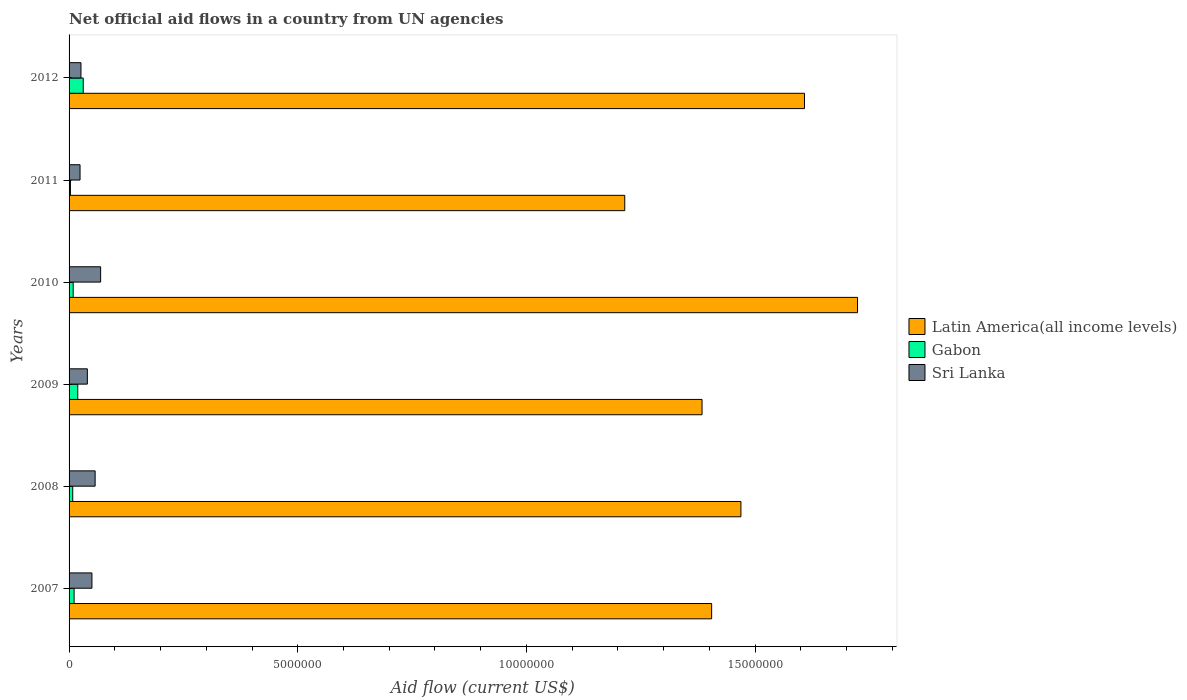How many different coloured bars are there?
Keep it short and to the point. 3. Are the number of bars on each tick of the Y-axis equal?
Your response must be concise. Yes. How many bars are there on the 6th tick from the top?
Your answer should be compact. 3. How many bars are there on the 5th tick from the bottom?
Your answer should be compact. 3. What is the label of the 6th group of bars from the top?
Your answer should be compact. 2007. What is the net official aid flow in Gabon in 2012?
Give a very brief answer. 3.10e+05. Across all years, what is the maximum net official aid flow in Sri Lanka?
Give a very brief answer. 6.90e+05. Across all years, what is the minimum net official aid flow in Gabon?
Your answer should be very brief. 3.00e+04. What is the total net official aid flow in Sri Lanka in the graph?
Offer a very short reply. 2.66e+06. What is the difference between the net official aid flow in Gabon in 2009 and that in 2011?
Make the answer very short. 1.60e+05. What is the difference between the net official aid flow in Gabon in 2009 and the net official aid flow in Latin America(all income levels) in 2007?
Make the answer very short. -1.39e+07. What is the average net official aid flow in Sri Lanka per year?
Make the answer very short. 4.43e+05. In the year 2012, what is the difference between the net official aid flow in Sri Lanka and net official aid flow in Latin America(all income levels)?
Your response must be concise. -1.58e+07. In how many years, is the net official aid flow in Gabon greater than 13000000 US$?
Give a very brief answer. 0. What is the ratio of the net official aid flow in Latin America(all income levels) in 2007 to that in 2011?
Keep it short and to the point. 1.16. Is the net official aid flow in Sri Lanka in 2010 less than that in 2012?
Your answer should be compact. No. Is the difference between the net official aid flow in Sri Lanka in 2008 and 2009 greater than the difference between the net official aid flow in Latin America(all income levels) in 2008 and 2009?
Your answer should be compact. No. What is the difference between the highest and the lowest net official aid flow in Latin America(all income levels)?
Ensure brevity in your answer.  5.09e+06. In how many years, is the net official aid flow in Gabon greater than the average net official aid flow in Gabon taken over all years?
Give a very brief answer. 2. What does the 2nd bar from the top in 2012 represents?
Provide a succinct answer. Gabon. What does the 2nd bar from the bottom in 2009 represents?
Provide a short and direct response. Gabon. How many bars are there?
Ensure brevity in your answer.  18. What is the difference between two consecutive major ticks on the X-axis?
Your answer should be compact. 5.00e+06. Are the values on the major ticks of X-axis written in scientific E-notation?
Offer a very short reply. No. Where does the legend appear in the graph?
Offer a terse response. Center right. How many legend labels are there?
Provide a short and direct response. 3. What is the title of the graph?
Your answer should be compact. Net official aid flows in a country from UN agencies. Does "Cuba" appear as one of the legend labels in the graph?
Keep it short and to the point. No. What is the label or title of the X-axis?
Ensure brevity in your answer.  Aid flow (current US$). What is the label or title of the Y-axis?
Your response must be concise. Years. What is the Aid flow (current US$) in Latin America(all income levels) in 2007?
Make the answer very short. 1.40e+07. What is the Aid flow (current US$) of Gabon in 2007?
Your answer should be compact. 1.10e+05. What is the Aid flow (current US$) in Latin America(all income levels) in 2008?
Offer a terse response. 1.47e+07. What is the Aid flow (current US$) of Sri Lanka in 2008?
Offer a terse response. 5.70e+05. What is the Aid flow (current US$) in Latin America(all income levels) in 2009?
Give a very brief answer. 1.38e+07. What is the Aid flow (current US$) in Gabon in 2009?
Provide a succinct answer. 1.90e+05. What is the Aid flow (current US$) in Sri Lanka in 2009?
Your response must be concise. 4.00e+05. What is the Aid flow (current US$) of Latin America(all income levels) in 2010?
Provide a succinct answer. 1.72e+07. What is the Aid flow (current US$) in Gabon in 2010?
Provide a short and direct response. 9.00e+04. What is the Aid flow (current US$) of Sri Lanka in 2010?
Your response must be concise. 6.90e+05. What is the Aid flow (current US$) of Latin America(all income levels) in 2011?
Ensure brevity in your answer.  1.22e+07. What is the Aid flow (current US$) of Gabon in 2011?
Provide a short and direct response. 3.00e+04. What is the Aid flow (current US$) in Sri Lanka in 2011?
Offer a terse response. 2.40e+05. What is the Aid flow (current US$) in Latin America(all income levels) in 2012?
Provide a succinct answer. 1.61e+07. What is the Aid flow (current US$) in Gabon in 2012?
Your response must be concise. 3.10e+05. What is the Aid flow (current US$) of Sri Lanka in 2012?
Provide a succinct answer. 2.60e+05. Across all years, what is the maximum Aid flow (current US$) in Latin America(all income levels)?
Keep it short and to the point. 1.72e+07. Across all years, what is the maximum Aid flow (current US$) in Gabon?
Give a very brief answer. 3.10e+05. Across all years, what is the maximum Aid flow (current US$) in Sri Lanka?
Your answer should be very brief. 6.90e+05. Across all years, what is the minimum Aid flow (current US$) of Latin America(all income levels)?
Provide a succinct answer. 1.22e+07. Across all years, what is the minimum Aid flow (current US$) of Sri Lanka?
Give a very brief answer. 2.40e+05. What is the total Aid flow (current US$) in Latin America(all income levels) in the graph?
Ensure brevity in your answer.  8.80e+07. What is the total Aid flow (current US$) of Gabon in the graph?
Keep it short and to the point. 8.10e+05. What is the total Aid flow (current US$) in Sri Lanka in the graph?
Keep it short and to the point. 2.66e+06. What is the difference between the Aid flow (current US$) of Latin America(all income levels) in 2007 and that in 2008?
Give a very brief answer. -6.40e+05. What is the difference between the Aid flow (current US$) in Latin America(all income levels) in 2007 and that in 2009?
Keep it short and to the point. 2.10e+05. What is the difference between the Aid flow (current US$) of Latin America(all income levels) in 2007 and that in 2010?
Provide a succinct answer. -3.19e+06. What is the difference between the Aid flow (current US$) in Gabon in 2007 and that in 2010?
Offer a very short reply. 2.00e+04. What is the difference between the Aid flow (current US$) of Latin America(all income levels) in 2007 and that in 2011?
Your response must be concise. 1.90e+06. What is the difference between the Aid flow (current US$) in Gabon in 2007 and that in 2011?
Give a very brief answer. 8.00e+04. What is the difference between the Aid flow (current US$) of Latin America(all income levels) in 2007 and that in 2012?
Your answer should be compact. -2.03e+06. What is the difference between the Aid flow (current US$) in Sri Lanka in 2007 and that in 2012?
Ensure brevity in your answer.  2.40e+05. What is the difference between the Aid flow (current US$) in Latin America(all income levels) in 2008 and that in 2009?
Ensure brevity in your answer.  8.50e+05. What is the difference between the Aid flow (current US$) of Gabon in 2008 and that in 2009?
Your answer should be compact. -1.10e+05. What is the difference between the Aid flow (current US$) of Sri Lanka in 2008 and that in 2009?
Your answer should be very brief. 1.70e+05. What is the difference between the Aid flow (current US$) in Latin America(all income levels) in 2008 and that in 2010?
Your answer should be very brief. -2.55e+06. What is the difference between the Aid flow (current US$) of Sri Lanka in 2008 and that in 2010?
Offer a very short reply. -1.20e+05. What is the difference between the Aid flow (current US$) in Latin America(all income levels) in 2008 and that in 2011?
Your answer should be compact. 2.54e+06. What is the difference between the Aid flow (current US$) in Gabon in 2008 and that in 2011?
Offer a very short reply. 5.00e+04. What is the difference between the Aid flow (current US$) of Latin America(all income levels) in 2008 and that in 2012?
Keep it short and to the point. -1.39e+06. What is the difference between the Aid flow (current US$) of Latin America(all income levels) in 2009 and that in 2010?
Give a very brief answer. -3.40e+06. What is the difference between the Aid flow (current US$) in Gabon in 2009 and that in 2010?
Keep it short and to the point. 1.00e+05. What is the difference between the Aid flow (current US$) in Sri Lanka in 2009 and that in 2010?
Your response must be concise. -2.90e+05. What is the difference between the Aid flow (current US$) of Latin America(all income levels) in 2009 and that in 2011?
Your answer should be compact. 1.69e+06. What is the difference between the Aid flow (current US$) in Gabon in 2009 and that in 2011?
Your response must be concise. 1.60e+05. What is the difference between the Aid flow (current US$) of Latin America(all income levels) in 2009 and that in 2012?
Make the answer very short. -2.24e+06. What is the difference between the Aid flow (current US$) in Sri Lanka in 2009 and that in 2012?
Give a very brief answer. 1.40e+05. What is the difference between the Aid flow (current US$) of Latin America(all income levels) in 2010 and that in 2011?
Make the answer very short. 5.09e+06. What is the difference between the Aid flow (current US$) of Latin America(all income levels) in 2010 and that in 2012?
Offer a very short reply. 1.16e+06. What is the difference between the Aid flow (current US$) in Sri Lanka in 2010 and that in 2012?
Your answer should be compact. 4.30e+05. What is the difference between the Aid flow (current US$) of Latin America(all income levels) in 2011 and that in 2012?
Your answer should be very brief. -3.93e+06. What is the difference between the Aid flow (current US$) of Gabon in 2011 and that in 2012?
Keep it short and to the point. -2.80e+05. What is the difference between the Aid flow (current US$) of Sri Lanka in 2011 and that in 2012?
Keep it short and to the point. -2.00e+04. What is the difference between the Aid flow (current US$) in Latin America(all income levels) in 2007 and the Aid flow (current US$) in Gabon in 2008?
Give a very brief answer. 1.40e+07. What is the difference between the Aid flow (current US$) of Latin America(all income levels) in 2007 and the Aid flow (current US$) of Sri Lanka in 2008?
Your answer should be very brief. 1.35e+07. What is the difference between the Aid flow (current US$) in Gabon in 2007 and the Aid flow (current US$) in Sri Lanka in 2008?
Keep it short and to the point. -4.60e+05. What is the difference between the Aid flow (current US$) of Latin America(all income levels) in 2007 and the Aid flow (current US$) of Gabon in 2009?
Keep it short and to the point. 1.39e+07. What is the difference between the Aid flow (current US$) in Latin America(all income levels) in 2007 and the Aid flow (current US$) in Sri Lanka in 2009?
Your answer should be compact. 1.36e+07. What is the difference between the Aid flow (current US$) in Latin America(all income levels) in 2007 and the Aid flow (current US$) in Gabon in 2010?
Keep it short and to the point. 1.40e+07. What is the difference between the Aid flow (current US$) of Latin America(all income levels) in 2007 and the Aid flow (current US$) of Sri Lanka in 2010?
Offer a terse response. 1.34e+07. What is the difference between the Aid flow (current US$) in Gabon in 2007 and the Aid flow (current US$) in Sri Lanka in 2010?
Your response must be concise. -5.80e+05. What is the difference between the Aid flow (current US$) in Latin America(all income levels) in 2007 and the Aid flow (current US$) in Gabon in 2011?
Your response must be concise. 1.40e+07. What is the difference between the Aid flow (current US$) in Latin America(all income levels) in 2007 and the Aid flow (current US$) in Sri Lanka in 2011?
Give a very brief answer. 1.38e+07. What is the difference between the Aid flow (current US$) of Latin America(all income levels) in 2007 and the Aid flow (current US$) of Gabon in 2012?
Ensure brevity in your answer.  1.37e+07. What is the difference between the Aid flow (current US$) in Latin America(all income levels) in 2007 and the Aid flow (current US$) in Sri Lanka in 2012?
Offer a very short reply. 1.38e+07. What is the difference between the Aid flow (current US$) in Gabon in 2007 and the Aid flow (current US$) in Sri Lanka in 2012?
Make the answer very short. -1.50e+05. What is the difference between the Aid flow (current US$) in Latin America(all income levels) in 2008 and the Aid flow (current US$) in Gabon in 2009?
Provide a short and direct response. 1.45e+07. What is the difference between the Aid flow (current US$) in Latin America(all income levels) in 2008 and the Aid flow (current US$) in Sri Lanka in 2009?
Give a very brief answer. 1.43e+07. What is the difference between the Aid flow (current US$) of Gabon in 2008 and the Aid flow (current US$) of Sri Lanka in 2009?
Your response must be concise. -3.20e+05. What is the difference between the Aid flow (current US$) of Latin America(all income levels) in 2008 and the Aid flow (current US$) of Gabon in 2010?
Keep it short and to the point. 1.46e+07. What is the difference between the Aid flow (current US$) of Latin America(all income levels) in 2008 and the Aid flow (current US$) of Sri Lanka in 2010?
Give a very brief answer. 1.40e+07. What is the difference between the Aid flow (current US$) of Gabon in 2008 and the Aid flow (current US$) of Sri Lanka in 2010?
Provide a short and direct response. -6.10e+05. What is the difference between the Aid flow (current US$) of Latin America(all income levels) in 2008 and the Aid flow (current US$) of Gabon in 2011?
Offer a very short reply. 1.47e+07. What is the difference between the Aid flow (current US$) in Latin America(all income levels) in 2008 and the Aid flow (current US$) in Sri Lanka in 2011?
Your answer should be compact. 1.44e+07. What is the difference between the Aid flow (current US$) of Gabon in 2008 and the Aid flow (current US$) of Sri Lanka in 2011?
Keep it short and to the point. -1.60e+05. What is the difference between the Aid flow (current US$) in Latin America(all income levels) in 2008 and the Aid flow (current US$) in Gabon in 2012?
Ensure brevity in your answer.  1.44e+07. What is the difference between the Aid flow (current US$) of Latin America(all income levels) in 2008 and the Aid flow (current US$) of Sri Lanka in 2012?
Your answer should be compact. 1.44e+07. What is the difference between the Aid flow (current US$) of Latin America(all income levels) in 2009 and the Aid flow (current US$) of Gabon in 2010?
Offer a very short reply. 1.38e+07. What is the difference between the Aid flow (current US$) in Latin America(all income levels) in 2009 and the Aid flow (current US$) in Sri Lanka in 2010?
Your response must be concise. 1.32e+07. What is the difference between the Aid flow (current US$) in Gabon in 2009 and the Aid flow (current US$) in Sri Lanka in 2010?
Your answer should be compact. -5.00e+05. What is the difference between the Aid flow (current US$) in Latin America(all income levels) in 2009 and the Aid flow (current US$) in Gabon in 2011?
Your answer should be compact. 1.38e+07. What is the difference between the Aid flow (current US$) in Latin America(all income levels) in 2009 and the Aid flow (current US$) in Sri Lanka in 2011?
Provide a short and direct response. 1.36e+07. What is the difference between the Aid flow (current US$) in Latin America(all income levels) in 2009 and the Aid flow (current US$) in Gabon in 2012?
Provide a succinct answer. 1.35e+07. What is the difference between the Aid flow (current US$) of Latin America(all income levels) in 2009 and the Aid flow (current US$) of Sri Lanka in 2012?
Your answer should be compact. 1.36e+07. What is the difference between the Aid flow (current US$) of Gabon in 2009 and the Aid flow (current US$) of Sri Lanka in 2012?
Offer a very short reply. -7.00e+04. What is the difference between the Aid flow (current US$) in Latin America(all income levels) in 2010 and the Aid flow (current US$) in Gabon in 2011?
Provide a succinct answer. 1.72e+07. What is the difference between the Aid flow (current US$) in Latin America(all income levels) in 2010 and the Aid flow (current US$) in Sri Lanka in 2011?
Offer a terse response. 1.70e+07. What is the difference between the Aid flow (current US$) of Gabon in 2010 and the Aid flow (current US$) of Sri Lanka in 2011?
Your answer should be very brief. -1.50e+05. What is the difference between the Aid flow (current US$) in Latin America(all income levels) in 2010 and the Aid flow (current US$) in Gabon in 2012?
Offer a very short reply. 1.69e+07. What is the difference between the Aid flow (current US$) of Latin America(all income levels) in 2010 and the Aid flow (current US$) of Sri Lanka in 2012?
Provide a short and direct response. 1.70e+07. What is the difference between the Aid flow (current US$) in Gabon in 2010 and the Aid flow (current US$) in Sri Lanka in 2012?
Your answer should be compact. -1.70e+05. What is the difference between the Aid flow (current US$) in Latin America(all income levels) in 2011 and the Aid flow (current US$) in Gabon in 2012?
Provide a succinct answer. 1.18e+07. What is the difference between the Aid flow (current US$) of Latin America(all income levels) in 2011 and the Aid flow (current US$) of Sri Lanka in 2012?
Your answer should be compact. 1.19e+07. What is the difference between the Aid flow (current US$) of Gabon in 2011 and the Aid flow (current US$) of Sri Lanka in 2012?
Offer a very short reply. -2.30e+05. What is the average Aid flow (current US$) of Latin America(all income levels) per year?
Provide a succinct answer. 1.47e+07. What is the average Aid flow (current US$) in Gabon per year?
Give a very brief answer. 1.35e+05. What is the average Aid flow (current US$) in Sri Lanka per year?
Your answer should be compact. 4.43e+05. In the year 2007, what is the difference between the Aid flow (current US$) of Latin America(all income levels) and Aid flow (current US$) of Gabon?
Your answer should be very brief. 1.39e+07. In the year 2007, what is the difference between the Aid flow (current US$) in Latin America(all income levels) and Aid flow (current US$) in Sri Lanka?
Your answer should be compact. 1.36e+07. In the year 2007, what is the difference between the Aid flow (current US$) of Gabon and Aid flow (current US$) of Sri Lanka?
Ensure brevity in your answer.  -3.90e+05. In the year 2008, what is the difference between the Aid flow (current US$) in Latin America(all income levels) and Aid flow (current US$) in Gabon?
Keep it short and to the point. 1.46e+07. In the year 2008, what is the difference between the Aid flow (current US$) of Latin America(all income levels) and Aid flow (current US$) of Sri Lanka?
Your response must be concise. 1.41e+07. In the year 2008, what is the difference between the Aid flow (current US$) of Gabon and Aid flow (current US$) of Sri Lanka?
Your response must be concise. -4.90e+05. In the year 2009, what is the difference between the Aid flow (current US$) in Latin America(all income levels) and Aid flow (current US$) in Gabon?
Give a very brief answer. 1.36e+07. In the year 2009, what is the difference between the Aid flow (current US$) in Latin America(all income levels) and Aid flow (current US$) in Sri Lanka?
Offer a terse response. 1.34e+07. In the year 2009, what is the difference between the Aid flow (current US$) of Gabon and Aid flow (current US$) of Sri Lanka?
Offer a very short reply. -2.10e+05. In the year 2010, what is the difference between the Aid flow (current US$) in Latin America(all income levels) and Aid flow (current US$) in Gabon?
Make the answer very short. 1.72e+07. In the year 2010, what is the difference between the Aid flow (current US$) in Latin America(all income levels) and Aid flow (current US$) in Sri Lanka?
Provide a short and direct response. 1.66e+07. In the year 2010, what is the difference between the Aid flow (current US$) in Gabon and Aid flow (current US$) in Sri Lanka?
Ensure brevity in your answer.  -6.00e+05. In the year 2011, what is the difference between the Aid flow (current US$) of Latin America(all income levels) and Aid flow (current US$) of Gabon?
Provide a short and direct response. 1.21e+07. In the year 2011, what is the difference between the Aid flow (current US$) of Latin America(all income levels) and Aid flow (current US$) of Sri Lanka?
Make the answer very short. 1.19e+07. In the year 2012, what is the difference between the Aid flow (current US$) in Latin America(all income levels) and Aid flow (current US$) in Gabon?
Offer a very short reply. 1.58e+07. In the year 2012, what is the difference between the Aid flow (current US$) of Latin America(all income levels) and Aid flow (current US$) of Sri Lanka?
Provide a succinct answer. 1.58e+07. What is the ratio of the Aid flow (current US$) of Latin America(all income levels) in 2007 to that in 2008?
Your answer should be compact. 0.96. What is the ratio of the Aid flow (current US$) in Gabon in 2007 to that in 2008?
Provide a short and direct response. 1.38. What is the ratio of the Aid flow (current US$) in Sri Lanka in 2007 to that in 2008?
Give a very brief answer. 0.88. What is the ratio of the Aid flow (current US$) of Latin America(all income levels) in 2007 to that in 2009?
Your response must be concise. 1.02. What is the ratio of the Aid flow (current US$) in Gabon in 2007 to that in 2009?
Offer a terse response. 0.58. What is the ratio of the Aid flow (current US$) of Latin America(all income levels) in 2007 to that in 2010?
Your answer should be compact. 0.81. What is the ratio of the Aid flow (current US$) in Gabon in 2007 to that in 2010?
Offer a very short reply. 1.22. What is the ratio of the Aid flow (current US$) in Sri Lanka in 2007 to that in 2010?
Provide a succinct answer. 0.72. What is the ratio of the Aid flow (current US$) in Latin America(all income levels) in 2007 to that in 2011?
Your answer should be compact. 1.16. What is the ratio of the Aid flow (current US$) of Gabon in 2007 to that in 2011?
Offer a terse response. 3.67. What is the ratio of the Aid flow (current US$) of Sri Lanka in 2007 to that in 2011?
Your response must be concise. 2.08. What is the ratio of the Aid flow (current US$) in Latin America(all income levels) in 2007 to that in 2012?
Your answer should be very brief. 0.87. What is the ratio of the Aid flow (current US$) in Gabon in 2007 to that in 2012?
Make the answer very short. 0.35. What is the ratio of the Aid flow (current US$) in Sri Lanka in 2007 to that in 2012?
Your answer should be very brief. 1.92. What is the ratio of the Aid flow (current US$) of Latin America(all income levels) in 2008 to that in 2009?
Offer a very short reply. 1.06. What is the ratio of the Aid flow (current US$) in Gabon in 2008 to that in 2009?
Offer a very short reply. 0.42. What is the ratio of the Aid flow (current US$) in Sri Lanka in 2008 to that in 2009?
Your answer should be compact. 1.43. What is the ratio of the Aid flow (current US$) in Latin America(all income levels) in 2008 to that in 2010?
Your answer should be very brief. 0.85. What is the ratio of the Aid flow (current US$) of Sri Lanka in 2008 to that in 2010?
Provide a succinct answer. 0.83. What is the ratio of the Aid flow (current US$) of Latin America(all income levels) in 2008 to that in 2011?
Offer a very short reply. 1.21. What is the ratio of the Aid flow (current US$) of Gabon in 2008 to that in 2011?
Your answer should be compact. 2.67. What is the ratio of the Aid flow (current US$) in Sri Lanka in 2008 to that in 2011?
Keep it short and to the point. 2.38. What is the ratio of the Aid flow (current US$) in Latin America(all income levels) in 2008 to that in 2012?
Offer a terse response. 0.91. What is the ratio of the Aid flow (current US$) in Gabon in 2008 to that in 2012?
Your answer should be compact. 0.26. What is the ratio of the Aid flow (current US$) in Sri Lanka in 2008 to that in 2012?
Provide a short and direct response. 2.19. What is the ratio of the Aid flow (current US$) of Latin America(all income levels) in 2009 to that in 2010?
Your response must be concise. 0.8. What is the ratio of the Aid flow (current US$) in Gabon in 2009 to that in 2010?
Make the answer very short. 2.11. What is the ratio of the Aid flow (current US$) in Sri Lanka in 2009 to that in 2010?
Keep it short and to the point. 0.58. What is the ratio of the Aid flow (current US$) of Latin America(all income levels) in 2009 to that in 2011?
Your answer should be compact. 1.14. What is the ratio of the Aid flow (current US$) of Gabon in 2009 to that in 2011?
Offer a terse response. 6.33. What is the ratio of the Aid flow (current US$) in Latin America(all income levels) in 2009 to that in 2012?
Offer a terse response. 0.86. What is the ratio of the Aid flow (current US$) in Gabon in 2009 to that in 2012?
Provide a short and direct response. 0.61. What is the ratio of the Aid flow (current US$) in Sri Lanka in 2009 to that in 2012?
Offer a terse response. 1.54. What is the ratio of the Aid flow (current US$) of Latin America(all income levels) in 2010 to that in 2011?
Offer a very short reply. 1.42. What is the ratio of the Aid flow (current US$) of Gabon in 2010 to that in 2011?
Your answer should be very brief. 3. What is the ratio of the Aid flow (current US$) of Sri Lanka in 2010 to that in 2011?
Your response must be concise. 2.88. What is the ratio of the Aid flow (current US$) of Latin America(all income levels) in 2010 to that in 2012?
Give a very brief answer. 1.07. What is the ratio of the Aid flow (current US$) in Gabon in 2010 to that in 2012?
Provide a short and direct response. 0.29. What is the ratio of the Aid flow (current US$) of Sri Lanka in 2010 to that in 2012?
Keep it short and to the point. 2.65. What is the ratio of the Aid flow (current US$) in Latin America(all income levels) in 2011 to that in 2012?
Your response must be concise. 0.76. What is the ratio of the Aid flow (current US$) in Gabon in 2011 to that in 2012?
Your answer should be compact. 0.1. What is the difference between the highest and the second highest Aid flow (current US$) of Latin America(all income levels)?
Provide a short and direct response. 1.16e+06. What is the difference between the highest and the second highest Aid flow (current US$) of Sri Lanka?
Provide a short and direct response. 1.20e+05. What is the difference between the highest and the lowest Aid flow (current US$) in Latin America(all income levels)?
Ensure brevity in your answer.  5.09e+06. 